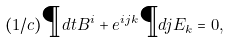<formula> <loc_0><loc_0><loc_500><loc_500>( 1 / c ) \P d { t } B ^ { i } + e ^ { i j k } \P d { j } E _ { k } = 0 ,</formula> 